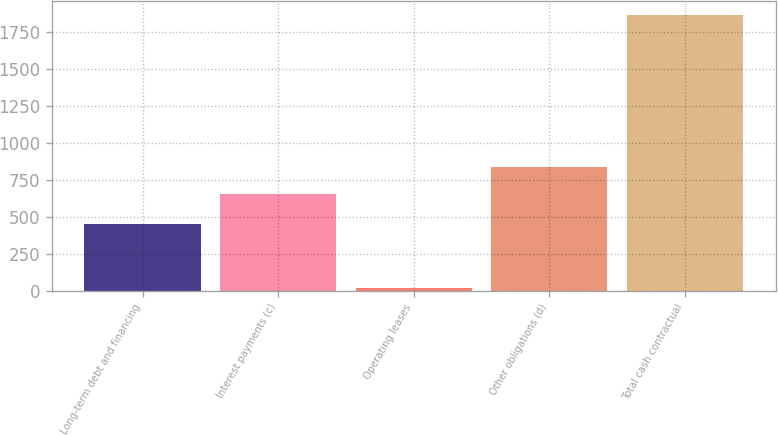Convert chart to OTSL. <chart><loc_0><loc_0><loc_500><loc_500><bar_chart><fcel>Long-term debt and financing<fcel>Interest payments (c)<fcel>Operating leases<fcel>Other obligations (d)<fcel>Total cash contractual<nl><fcel>450<fcel>653<fcel>15<fcel>837.9<fcel>1864<nl></chart> 